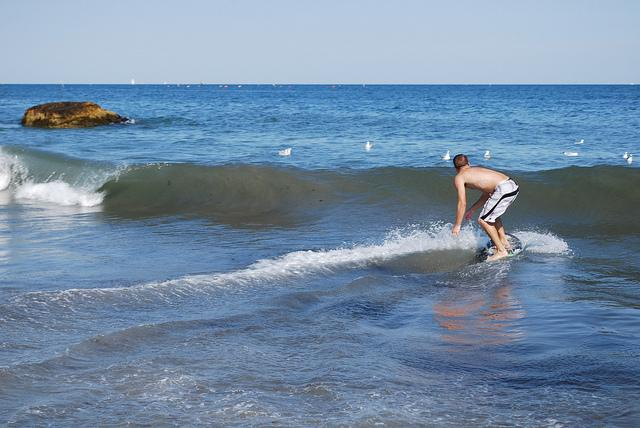Why is he crouching over?

Choices:
A) shorter fall
B) stay warmer
C) less wind
D) maintain balance maintain balance 